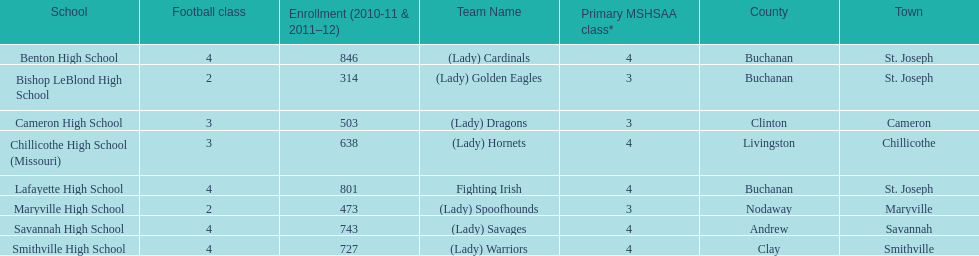What is the lowest number of students enrolled at a school as listed here? 314. What school has 314 students enrolled? Bishop LeBlond High School. Can you give me this table as a dict? {'header': ['School', 'Football class', 'Enrollment (2010-11 & 2011–12)', 'Team Name', 'Primary MSHSAA class*', 'County', 'Town'], 'rows': [['Benton High School', '4', '846', '(Lady) Cardinals', '4', 'Buchanan', 'St. Joseph'], ['Bishop LeBlond High School', '2', '314', '(Lady) Golden Eagles', '3', 'Buchanan', 'St. Joseph'], ['Cameron High School', '3', '503', '(Lady) Dragons', '3', 'Clinton', 'Cameron'], ['Chillicothe High School (Missouri)', '3', '638', '(Lady) Hornets', '4', 'Livingston', 'Chillicothe'], ['Lafayette High School', '4', '801', 'Fighting Irish', '4', 'Buchanan', 'St. Joseph'], ['Maryville High School', '2', '473', '(Lady) Spoofhounds', '3', 'Nodaway', 'Maryville'], ['Savannah High School', '4', '743', '(Lady) Savages', '4', 'Andrew', 'Savannah'], ['Smithville High School', '4', '727', '(Lady) Warriors', '4', 'Clay', 'Smithville']]} 